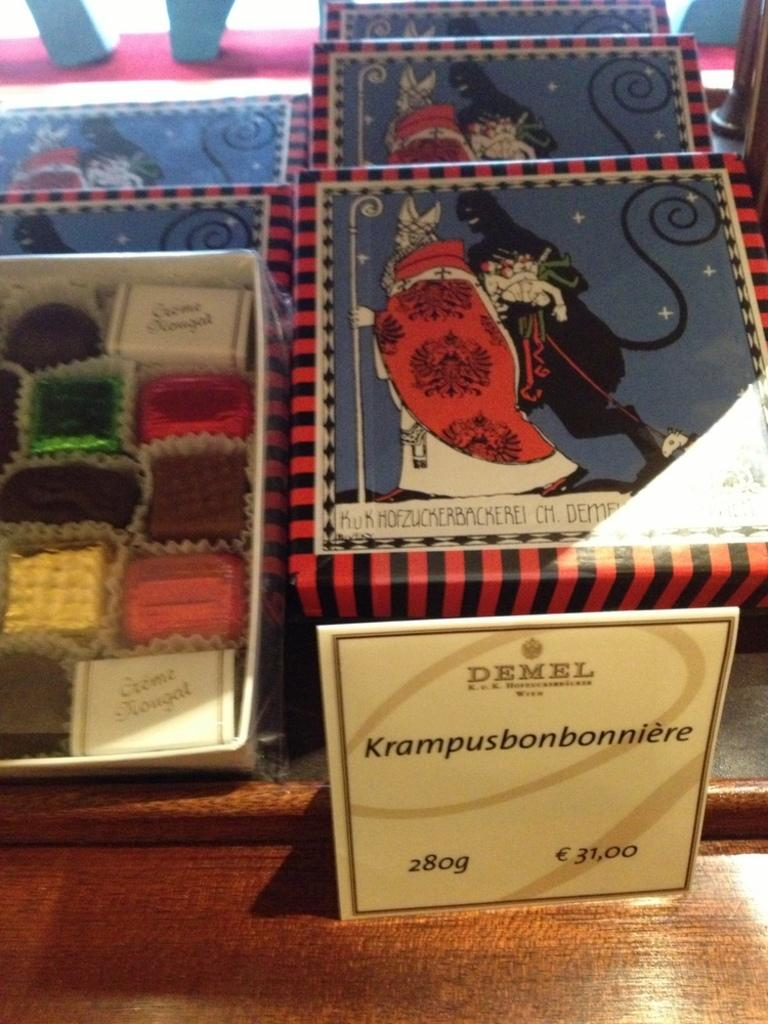<image>
Summarize the visual content of the image. a colorful box of chocolates from Demel weighing 280 g 